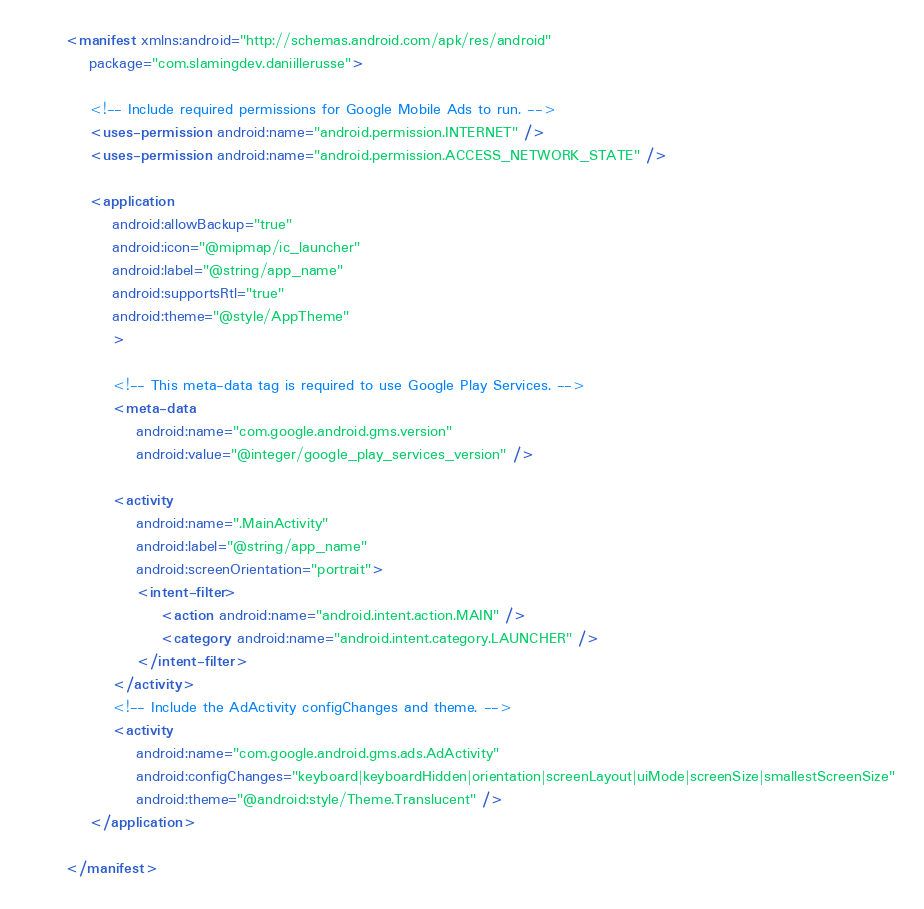Convert code to text. <code><loc_0><loc_0><loc_500><loc_500><_XML_><manifest xmlns:android="http://schemas.android.com/apk/res/android"
    package="com.slamingdev.daniillerusse">

    <!-- Include required permissions for Google Mobile Ads to run. -->
    <uses-permission android:name="android.permission.INTERNET" />
    <uses-permission android:name="android.permission.ACCESS_NETWORK_STATE" />

    <application
        android:allowBackup="true"
        android:icon="@mipmap/ic_launcher"
        android:label="@string/app_name"
        android:supportsRtl="true"
        android:theme="@style/AppTheme"
        >

        <!-- This meta-data tag is required to use Google Play Services. -->
        <meta-data
            android:name="com.google.android.gms.version"
            android:value="@integer/google_play_services_version" />

        <activity
            android:name=".MainActivity"
            android:label="@string/app_name"
            android:screenOrientation="portrait">
            <intent-filter>
                <action android:name="android.intent.action.MAIN" />
                <category android:name="android.intent.category.LAUNCHER" />
            </intent-filter>
        </activity>
        <!-- Include the AdActivity configChanges and theme. -->
        <activity
            android:name="com.google.android.gms.ads.AdActivity"
            android:configChanges="keyboard|keyboardHidden|orientation|screenLayout|uiMode|screenSize|smallestScreenSize"
            android:theme="@android:style/Theme.Translucent" />
    </application>

</manifest>
</code> 